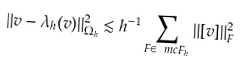<formula> <loc_0><loc_0><loc_500><loc_500>\| v - \lambda _ { h } ( v ) \| ^ { 2 } _ { \Omega _ { h } } \lesssim h ^ { - 1 } \sum _ { F \in \ m c F _ { h } } \| [ v ] \| ^ { 2 } _ { F }</formula> 